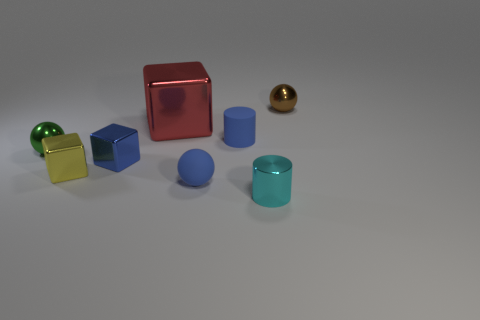There is a small shiny object that is the same color as the tiny rubber ball; what is its shape?
Offer a terse response. Cube. How many things are small cyan metallic cylinders that are in front of the small yellow shiny cube or blocks?
Ensure brevity in your answer.  4. The small blue thing that is behind the yellow object and in front of the blue cylinder has what shape?
Make the answer very short. Cube. How many objects are small cubes that are in front of the small blue metal cube or blue things that are left of the rubber cylinder?
Make the answer very short. 3. What number of other objects are the same size as the cyan object?
Keep it short and to the point. 6. Does the tiny cylinder left of the cyan thing have the same color as the tiny metal cylinder?
Provide a succinct answer. No. How big is the shiny cube that is in front of the blue cylinder and behind the tiny yellow shiny cube?
Your answer should be compact. Small. How many big objects are yellow matte things or cylinders?
Keep it short and to the point. 0. The tiny rubber object in front of the blue metallic block has what shape?
Provide a succinct answer. Sphere. How many large metallic objects are there?
Your answer should be very brief. 1. 